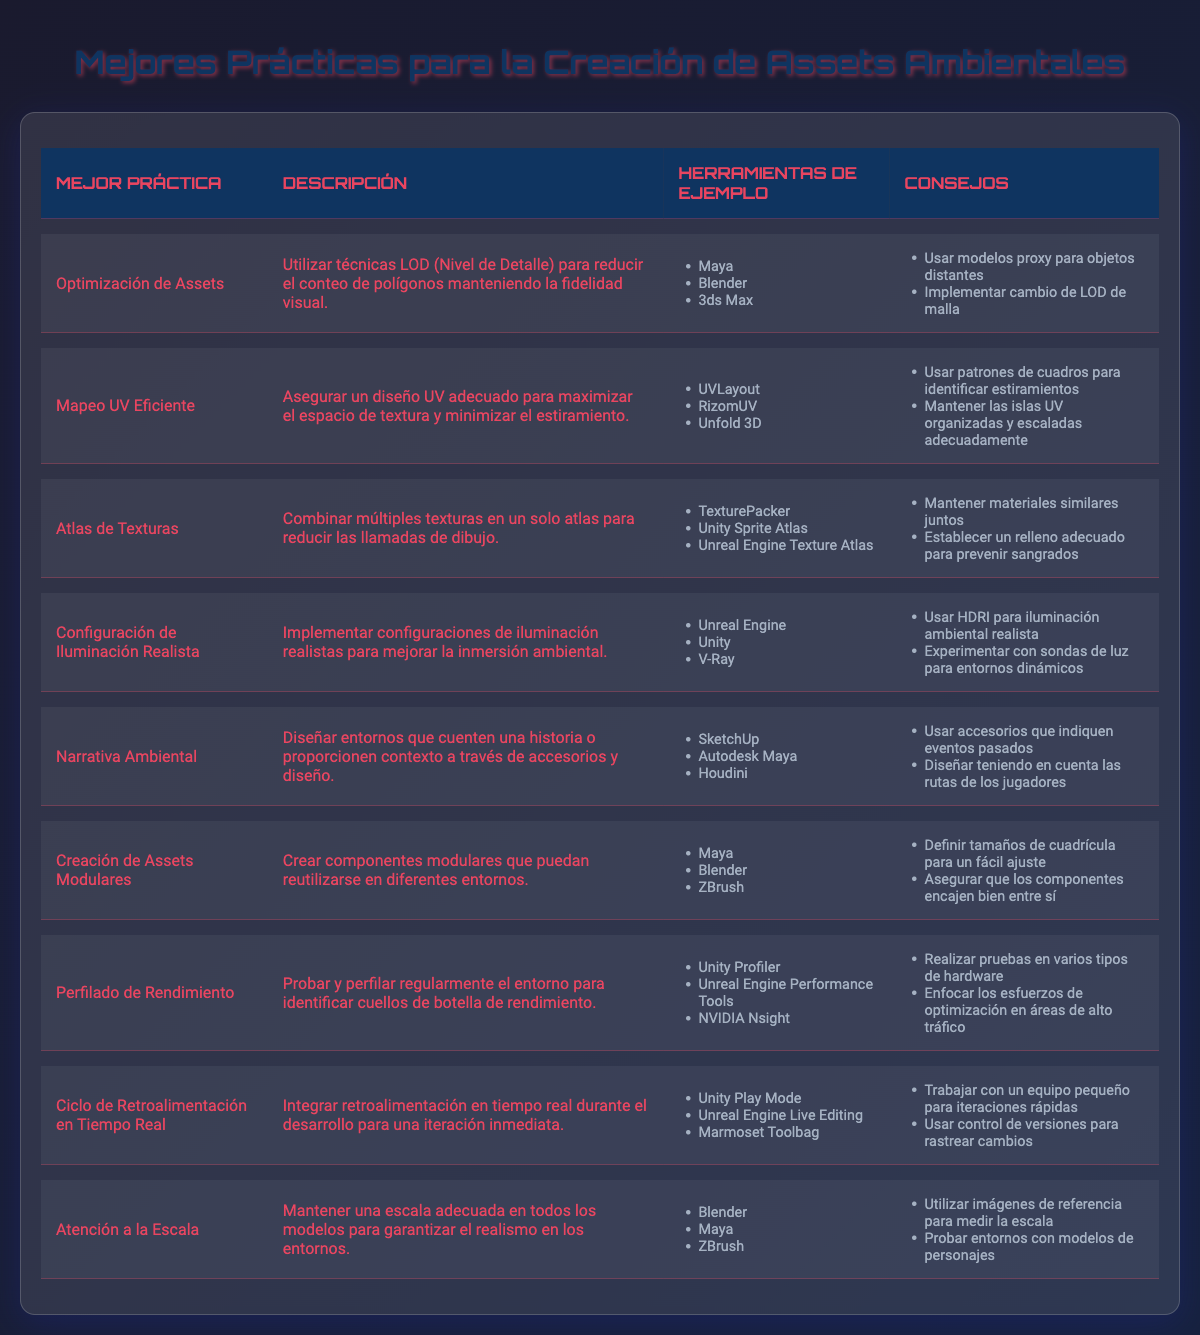¿Qué práctica se relaciona con el uso de técnicas LOD? La práctica que se relaciona con el uso de técnicas LOD es "Optimización de Assets". Esta información se encuentra en la primera fila de la tabla donde se lista la mejor práctica y su descripción.
Answer: Optimización de Assets ¿Cuáles son las herramientas de ejemplo para el "Mapeo UV Eficiente"? En la tabla, bajo la columna "Herramientas de Ejemplo" para "Mapeo UV Eficiente", se enumeran UVLayout, RizomUV y Unfold 3D. Se puede obtener directamente de esa fila.
Answer: UVLayout, RizomUV, Unfold 3D ¿Cuántas prácticas se centran en la optimización del rendimiento? Al observar la tabla, las prácticas que mencionan directamente la optimización del rendimiento son "Perfilado de Rendimiento" y "Optimización de Assets". Esto nos da un total de 2 prácticas relacionadas con la optimización.
Answer: 2 ¿Es verdadero que "Textura Atlasing" ayuda a reducir las llamadas de dibujo? En la descripción de "Textura Atlasing" se afirma que se combinan múltiples texturas en un solo atlas para reducir las llamadas de dibujo. Así que la afirmación es verdadera.
Answer: Verdadero ¿Qué práctica incluye el uso de HDRI para la iluminación ambiental? La práctica que menciona el uso de HDRI para iluminación ambiental es "Configuración de Iluminación Realista". Se puede encontrar esa información en su descripción.
Answer: Configuración de Iluminación Realista ¿Cuáles son los consejos específicos para "Creación de Assets Modulares"? En la fila de "Creación de Assets Modulares", los consejos proporcionados son definir tamaños de cuadrícula para un fácil ajuste y asegurar que los componentes encajen bien entre sí. Ambos se pueden leer directamente en la tabla.
Answer: Definir tamaños de cuadrícula para un fácil ajuste, asegurar que los componentes encajen bien entre sí ¿Cuál es la práctica que promueve la reutilización de componentes en diferentes entornos? La práctica que favorece la reutilización de componentes es "Creación de Assets Modulares". Esta información se encuentra en la descripción de la correspondiente fila.
Answer: Creación de Assets Modulares ¿Cuántas herramientas se mencionan para la "Atención a la Escala"? En la tabla, la práctica "Atención a la Escala" tiene tres herramientas mencionadas: Blender, Maya y ZBrush. Esto indica que hay un total de 3 herramientas expuestas para esta práctica.
Answer: 3 ¿Existen más de cinco herramientas diferentes mencionadas en la tabla? Al revisar todas las herramientas de las diferentes prácticas, se pueden contar más de cinco herramientas diferentes combinadas. Por lo tanto, la respuesta es afirmativa.
Answer: Verdadero ¿Qué tipos de herramientas de ejemplo se utilizan para la creación de activos en "Narrativa Ambiental"? Para "Narrativa Ambiental", las herramientas de ejemplo listadas son SketchUp, Autodesk Maya y Houdini. Se puede verificar esta información en la tabla.
Answer: SketchUp, Autodesk Maya, Houdini 